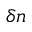Convert formula to latex. <formula><loc_0><loc_0><loc_500><loc_500>\delta n</formula> 